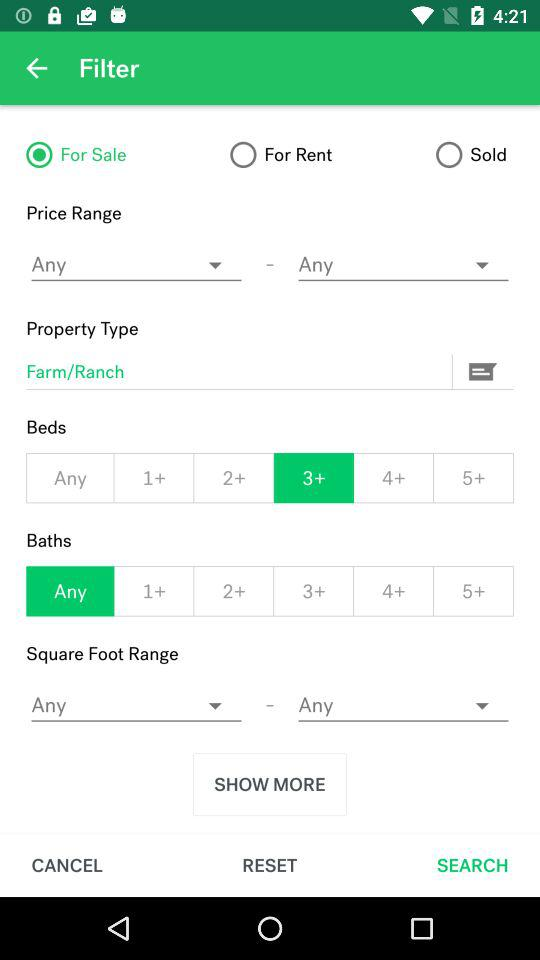What is the property type? The property type is farm or ranch. 